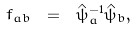<formula> <loc_0><loc_0><loc_500><loc_500>f _ { a b } \ = \ \hat { \psi } _ { a } ^ { - 1 } \hat { \psi } _ { b } ,</formula> 